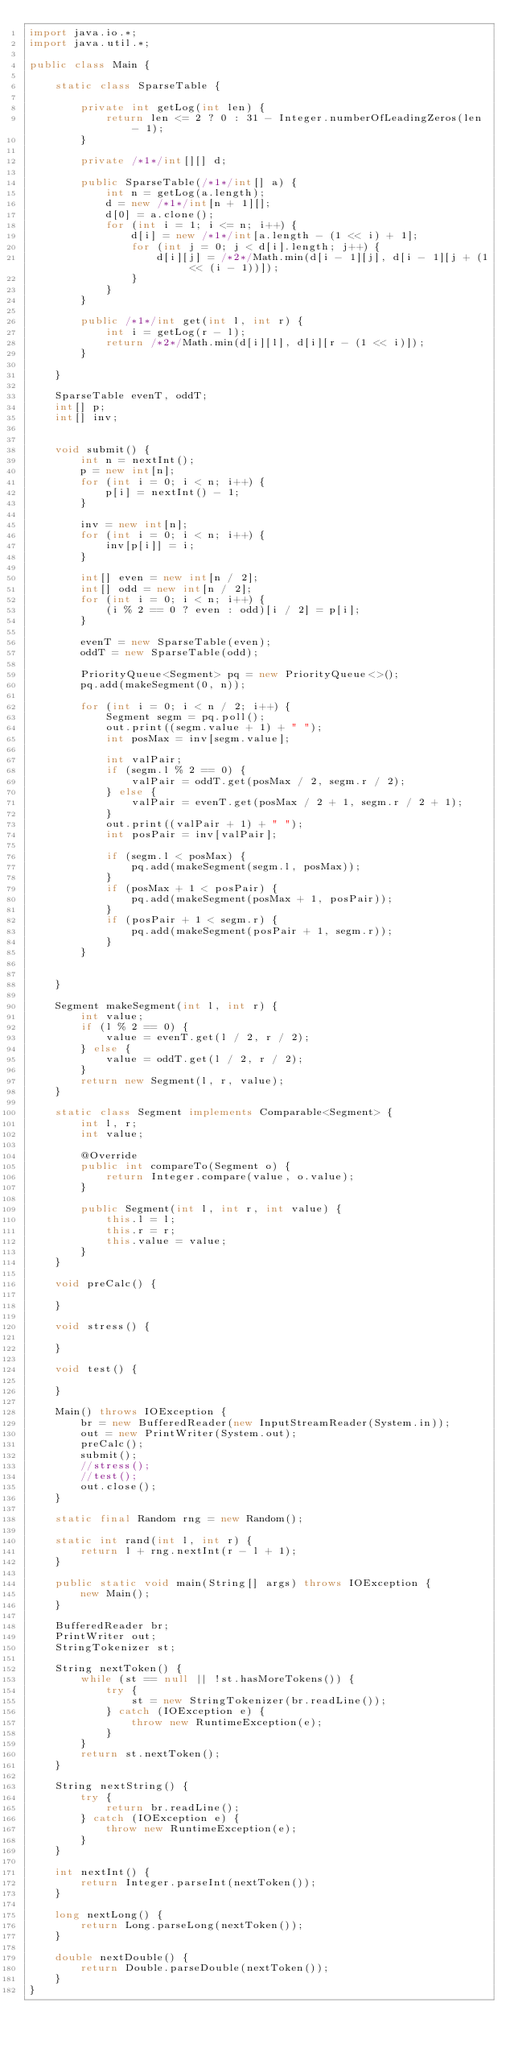Convert code to text. <code><loc_0><loc_0><loc_500><loc_500><_Java_>import java.io.*;
import java.util.*;

public class Main {

	static class SparseTable {

		private int getLog(int len) {
			return len <= 2 ? 0 : 31 - Integer.numberOfLeadingZeros(len - 1);
		}

		private /*1*/int[][] d;

		public SparseTable(/*1*/int[] a) {
			int n = getLog(a.length);
			d = new /*1*/int[n + 1][];
			d[0] = a.clone();
			for (int i = 1; i <= n; i++) {
				d[i] = new /*1*/int[a.length - (1 << i) + 1];
				for (int j = 0; j < d[i].length; j++) {
					d[i][j] = /*2*/Math.min(d[i - 1][j], d[i - 1][j + (1 << (i - 1))]);
				}
			}
		}

		public /*1*/int get(int l, int r) {
			int i = getLog(r - l);
			return /*2*/Math.min(d[i][l], d[i][r - (1 << i)]);
		}

	}
	
	SparseTable evenT, oddT;
	int[] p;
	int[] inv;
	
	
	void submit() {
		int n = nextInt();
		p = new int[n];
		for (int i = 0; i < n; i++) {
			p[i] = nextInt() - 1;
		}
		
		inv = new int[n];
		for (int i = 0; i < n; i++) {
			inv[p[i]] = i;
		}
	
		int[] even = new int[n / 2];
		int[] odd = new int[n / 2];
		for (int i = 0; i < n; i++) {
			(i % 2 == 0 ? even : odd)[i / 2] = p[i];
		}
		
		evenT = new SparseTable(even);
		oddT = new SparseTable(odd);
		
		PriorityQueue<Segment> pq = new PriorityQueue<>();
		pq.add(makeSegment(0, n));
		
		for (int i = 0; i < n / 2; i++) {
			Segment segm = pq.poll();
			out.print((segm.value + 1) + " ");
			int posMax = inv[segm.value];
			
			int valPair;
			if (segm.l % 2 == 0) {
				valPair = oddT.get(posMax / 2, segm.r / 2);
			} else {
				valPair = evenT.get(posMax / 2 + 1, segm.r / 2 + 1);
			}
			out.print((valPair + 1) + " ");
			int posPair = inv[valPair];
			
			if (segm.l < posMax) {
				pq.add(makeSegment(segm.l, posMax));
			}
			if (posMax + 1 < posPair) {
				pq.add(makeSegment(posMax + 1, posPair));
			}
			if (posPair + 1 < segm.r) {
				pq.add(makeSegment(posPair + 1, segm.r));
			}
		}
		
		
	}
	
	Segment makeSegment(int l, int r) {
		int value;
		if (l % 2 == 0) {
			value = evenT.get(l / 2, r / 2);
		} else {
			value = oddT.get(l / 2, r / 2);
		}
		return new Segment(l, r, value);
	}
	
	static class Segment implements Comparable<Segment> {
		int l, r;
		int value;
		
		@Override
		public int compareTo(Segment o) {
			return Integer.compare(value, o.value);
		}

		public Segment(int l, int r, int value) {
			this.l = l;
			this.r = r;
			this.value = value;
		}
	}

	void preCalc() {

	}

	void stress() {

	}

	void test() {

	}

	Main() throws IOException {
		br = new BufferedReader(new InputStreamReader(System.in));
		out = new PrintWriter(System.out);
		preCalc();
		submit();
		//stress();
		//test();
		out.close();
	}

	static final Random rng = new Random();

	static int rand(int l, int r) {
		return l + rng.nextInt(r - l + 1);
	}

	public static void main(String[] args) throws IOException {
		new Main();
	}

	BufferedReader br;
	PrintWriter out;
	StringTokenizer st;

	String nextToken() {
		while (st == null || !st.hasMoreTokens()) {
			try {
				st = new StringTokenizer(br.readLine());
			} catch (IOException e) {
				throw new RuntimeException(e);
			}
		}
		return st.nextToken();
	}

	String nextString() {
		try {
			return br.readLine();
		} catch (IOException e) {
			throw new RuntimeException(e);
		}
	}

	int nextInt() {
		return Integer.parseInt(nextToken());
	}

	long nextLong() {
		return Long.parseLong(nextToken());
	}

	double nextDouble() {
		return Double.parseDouble(nextToken());
	}
}
</code> 